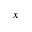<formula> <loc_0><loc_0><loc_500><loc_500>x</formula> 